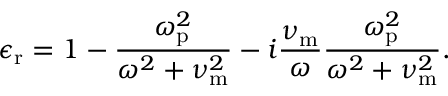Convert formula to latex. <formula><loc_0><loc_0><loc_500><loc_500>\epsilon _ { r } = 1 - \frac { \omega _ { p } ^ { 2 } } { \omega ^ { 2 } + \nu _ { m } ^ { 2 } } - i \frac { \nu _ { m } } { \omega } \frac { \omega _ { p } ^ { 2 } } { \omega ^ { 2 } + \nu _ { m } ^ { 2 } } .</formula> 